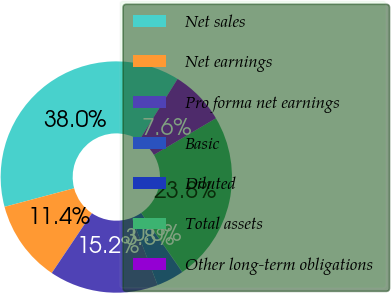Convert chart to OTSL. <chart><loc_0><loc_0><loc_500><loc_500><pie_chart><fcel>Net sales<fcel>Net earnings<fcel>Pro forma net earnings<fcel>Basic<fcel>Diluted<fcel>Total assets<fcel>Other long-term obligations<nl><fcel>38.03%<fcel>11.43%<fcel>15.23%<fcel>3.84%<fcel>0.04%<fcel>23.8%<fcel>7.63%<nl></chart> 